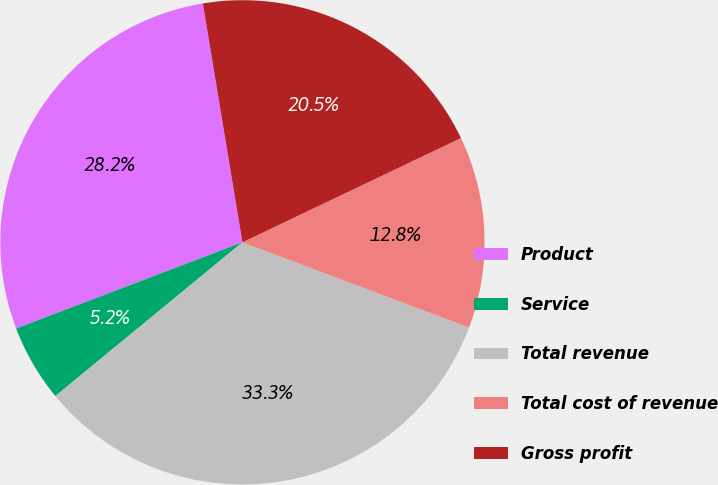Convert chart. <chart><loc_0><loc_0><loc_500><loc_500><pie_chart><fcel>Product<fcel>Service<fcel>Total revenue<fcel>Total cost of revenue<fcel>Gross profit<nl><fcel>28.18%<fcel>5.16%<fcel>33.33%<fcel>12.81%<fcel>20.53%<nl></chart> 